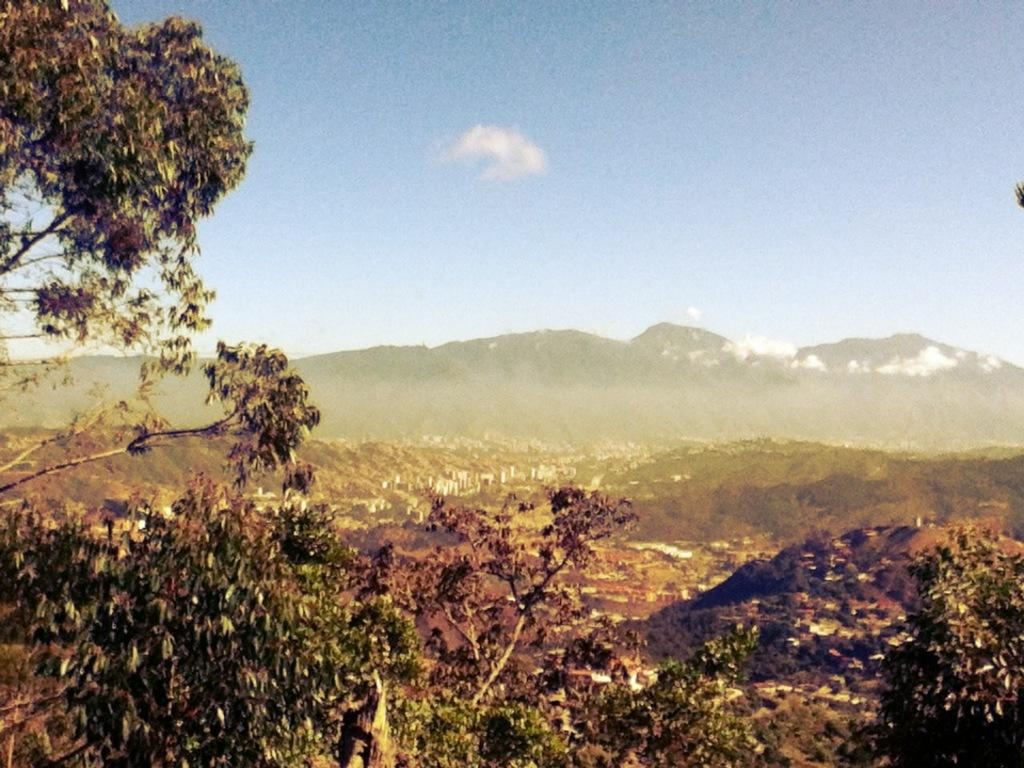What type of vegetation is in the front of the image? There are trees in the front of the image. What geographical features can be seen in the background of the image? There are hills visible in the background of the image. What is visible at the top of the image? The sky is visible at the top of the image. Can you tell me how many requests are being made in the image? There is no mention of requests in the image, as it features trees, hills, and the sky. Is there a hospital visible in the image? There is no hospital present in the image; it features trees, hills, and the sky. 